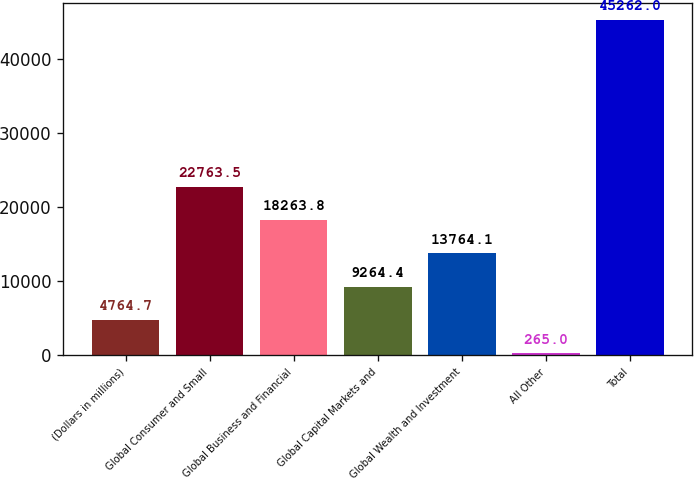Convert chart to OTSL. <chart><loc_0><loc_0><loc_500><loc_500><bar_chart><fcel>(Dollars in millions)<fcel>Global Consumer and Small<fcel>Global Business and Financial<fcel>Global Capital Markets and<fcel>Global Wealth and Investment<fcel>All Other<fcel>Total<nl><fcel>4764.7<fcel>22763.5<fcel>18263.8<fcel>9264.4<fcel>13764.1<fcel>265<fcel>45262<nl></chart> 